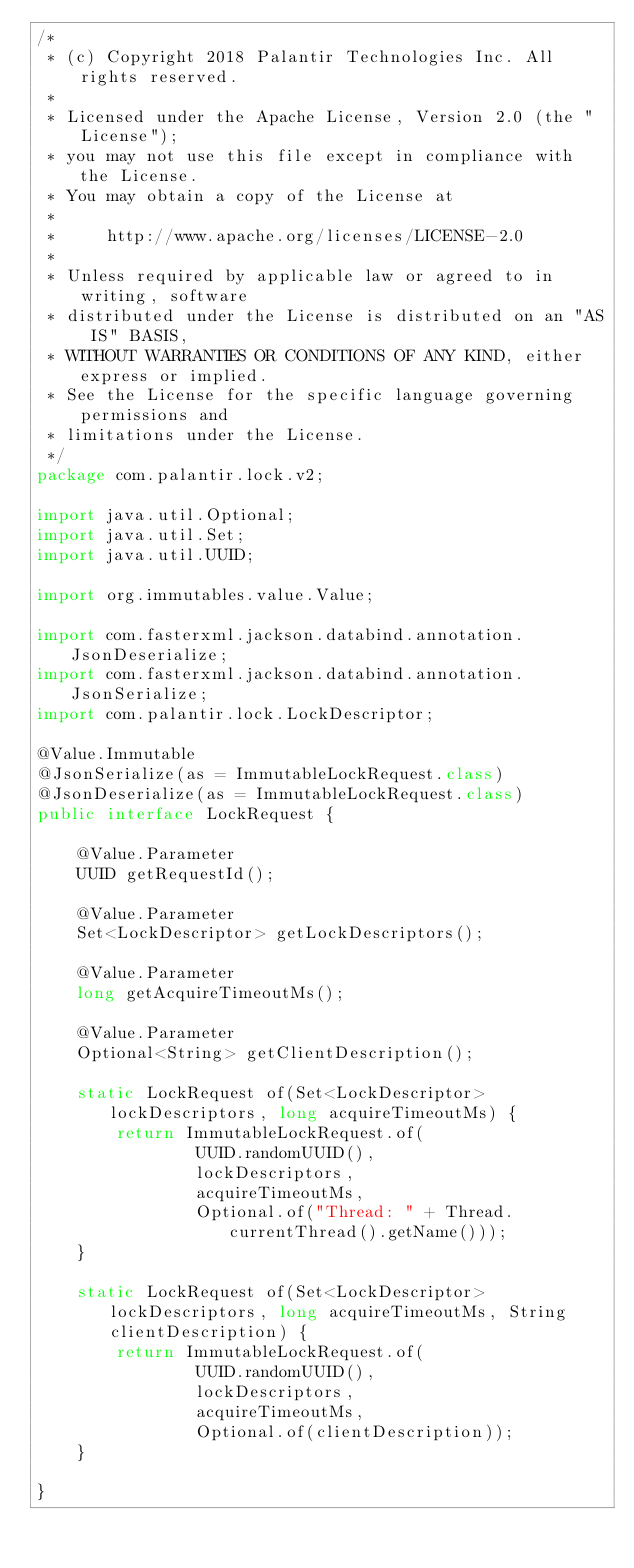<code> <loc_0><loc_0><loc_500><loc_500><_Java_>/*
 * (c) Copyright 2018 Palantir Technologies Inc. All rights reserved.
 *
 * Licensed under the Apache License, Version 2.0 (the "License");
 * you may not use this file except in compliance with the License.
 * You may obtain a copy of the License at
 *
 *     http://www.apache.org/licenses/LICENSE-2.0
 *
 * Unless required by applicable law or agreed to in writing, software
 * distributed under the License is distributed on an "AS IS" BASIS,
 * WITHOUT WARRANTIES OR CONDITIONS OF ANY KIND, either express or implied.
 * See the License for the specific language governing permissions and
 * limitations under the License.
 */
package com.palantir.lock.v2;

import java.util.Optional;
import java.util.Set;
import java.util.UUID;

import org.immutables.value.Value;

import com.fasterxml.jackson.databind.annotation.JsonDeserialize;
import com.fasterxml.jackson.databind.annotation.JsonSerialize;
import com.palantir.lock.LockDescriptor;

@Value.Immutable
@JsonSerialize(as = ImmutableLockRequest.class)
@JsonDeserialize(as = ImmutableLockRequest.class)
public interface LockRequest {

    @Value.Parameter
    UUID getRequestId();

    @Value.Parameter
    Set<LockDescriptor> getLockDescriptors();

    @Value.Parameter
    long getAcquireTimeoutMs();

    @Value.Parameter
    Optional<String> getClientDescription();

    static LockRequest of(Set<LockDescriptor> lockDescriptors, long acquireTimeoutMs) {
        return ImmutableLockRequest.of(
                UUID.randomUUID(),
                lockDescriptors,
                acquireTimeoutMs,
                Optional.of("Thread: " + Thread.currentThread().getName()));
    }

    static LockRequest of(Set<LockDescriptor> lockDescriptors, long acquireTimeoutMs, String clientDescription) {
        return ImmutableLockRequest.of(
                UUID.randomUUID(),
                lockDescriptors,
                acquireTimeoutMs,
                Optional.of(clientDescription));
    }

}
</code> 